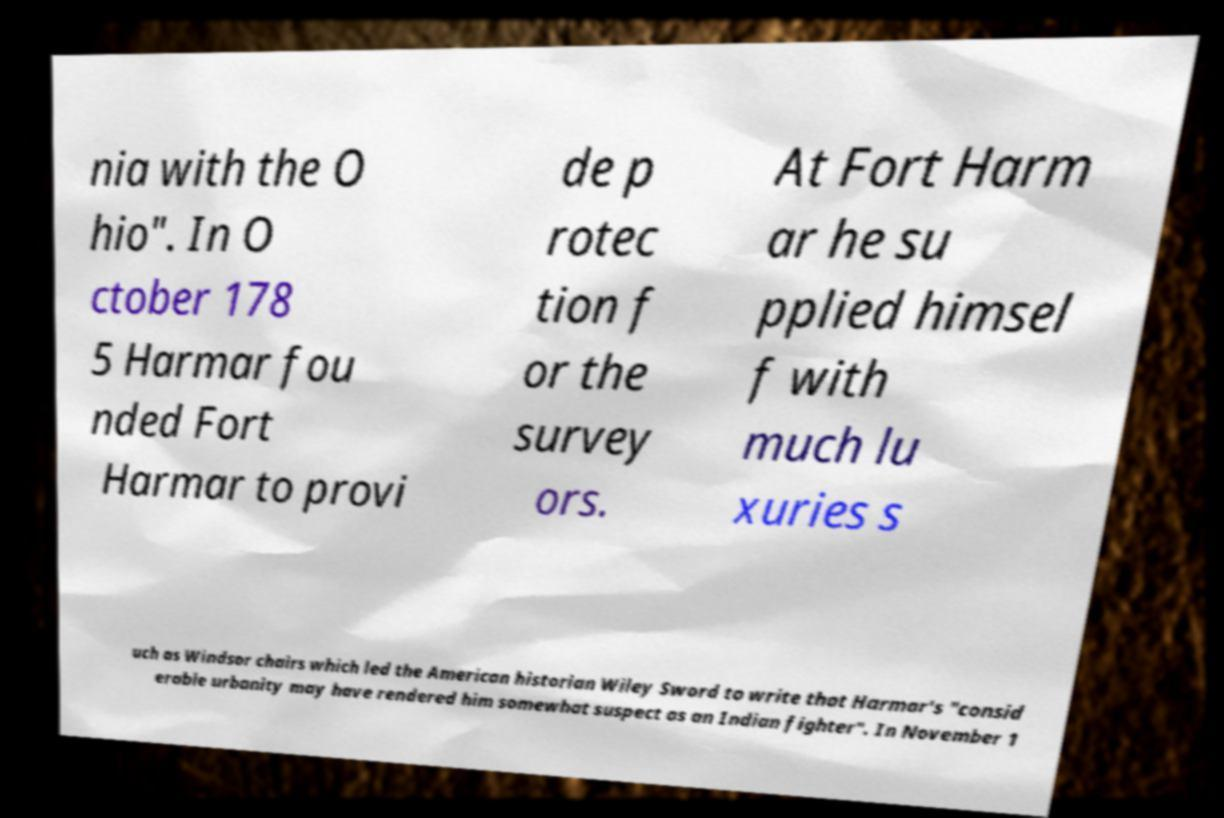Please read and relay the text visible in this image. What does it say? nia with the O hio". In O ctober 178 5 Harmar fou nded Fort Harmar to provi de p rotec tion f or the survey ors. At Fort Harm ar he su pplied himsel f with much lu xuries s uch as Windsor chairs which led the American historian Wiley Sword to write that Harmar's "consid erable urbanity may have rendered him somewhat suspect as an Indian fighter". In November 1 